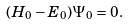Convert formula to latex. <formula><loc_0><loc_0><loc_500><loc_500>( H _ { 0 } - E _ { 0 } ) \Psi _ { 0 } = 0 .</formula> 